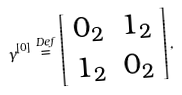<formula> <loc_0><loc_0><loc_500><loc_500>\gamma ^ { \left [ 0 \right ] } \stackrel { D e f } { = } \left [ \begin{array} { c c } 0 _ { 2 } & 1 _ { 2 } \\ 1 _ { 2 } & 0 _ { 2 } \end{array} \right ] ,</formula> 